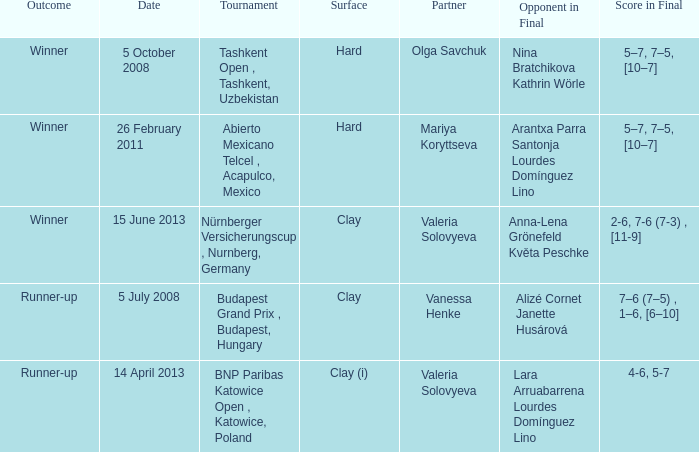Which partner was on 14 april 2013? Valeria Solovyeva. 